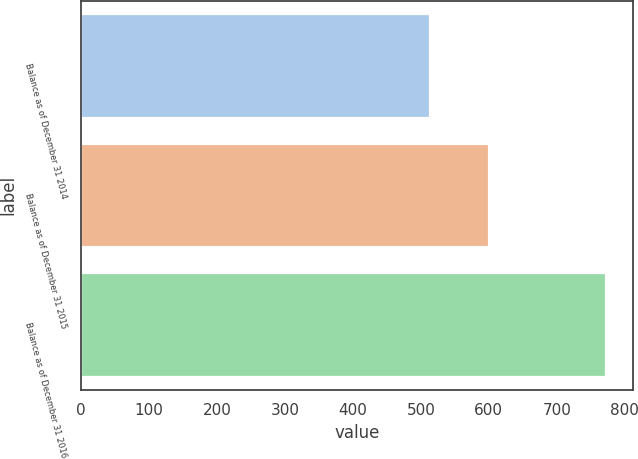Convert chart to OTSL. <chart><loc_0><loc_0><loc_500><loc_500><bar_chart><fcel>Balance as of December 31 2014<fcel>Balance as of December 31 2015<fcel>Balance as of December 31 2016<nl><fcel>514<fcel>600<fcel>773<nl></chart> 